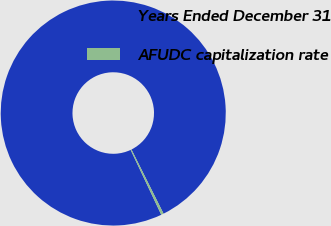Convert chart to OTSL. <chart><loc_0><loc_0><loc_500><loc_500><pie_chart><fcel>Years Ended December 31<fcel>AFUDC capitalization rate<nl><fcel>99.64%<fcel>0.36%<nl></chart> 